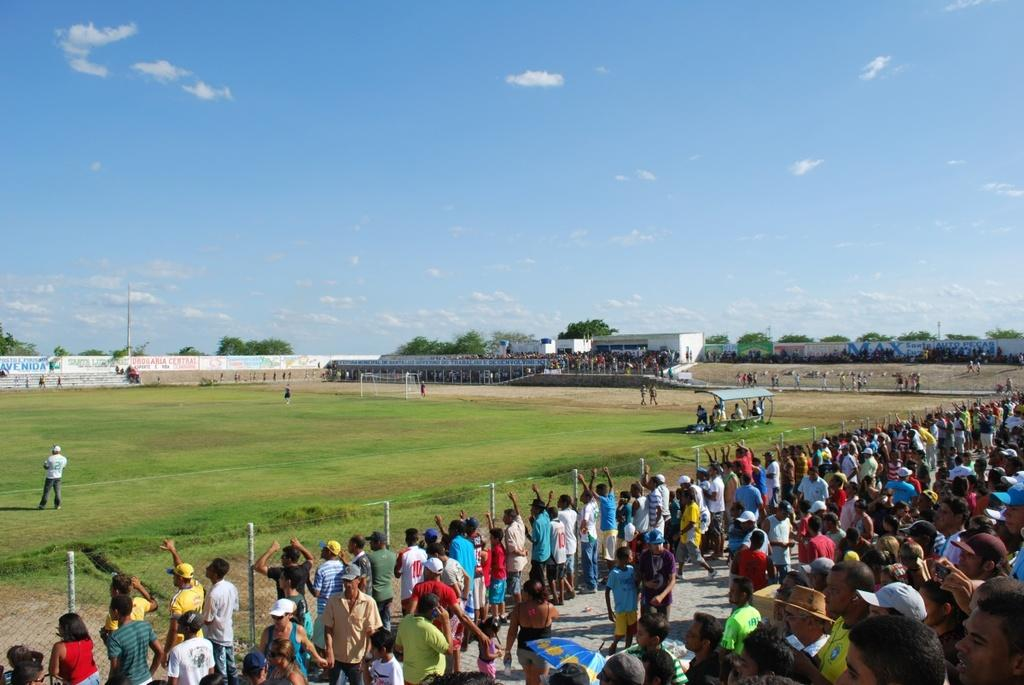How many people are in the image? There is a group of people in the image, but the exact number cannot be determined from the provided facts. What can be seen in the background of the image? There is a fence, grass, buildings, trees, a current pole, and the sky visible in the image. What is the condition of the sky in the image? The sky is visible in the image, and clouds are present. What type of story is being told by the hook in the image? There is no hook present in the image, so no story can be associated with it. 